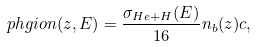Convert formula to latex. <formula><loc_0><loc_0><loc_500><loc_500>\ p h g i o n ( z , E ) = \frac { \sigma _ { H e + H } ( E ) } { 1 6 } n _ { b } ( z ) c ,</formula> 